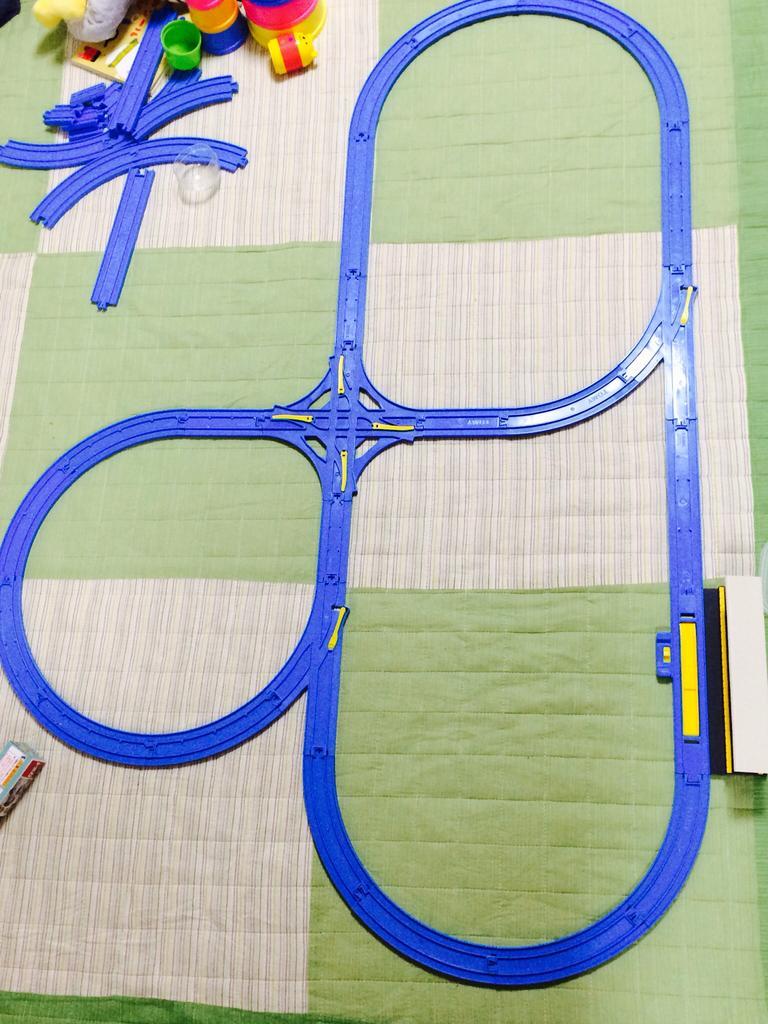Describe this image in one or two sentences. In this image in the center there is a toy railway track which is blue in colour and there are toys which are pink and yellow in colour and green in colour. 